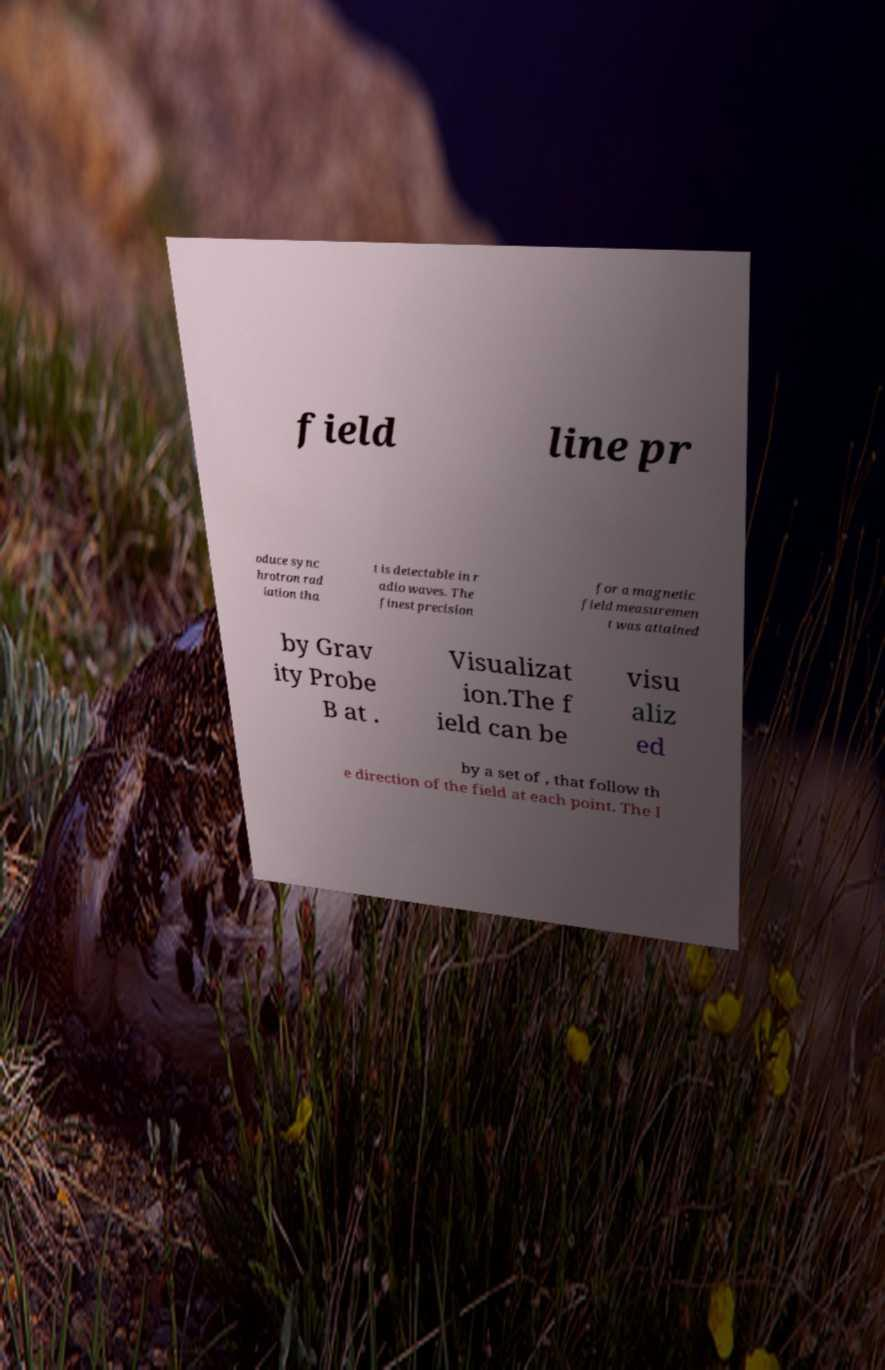What messages or text are displayed in this image? I need them in a readable, typed format. field line pr oduce sync hrotron rad iation tha t is detectable in r adio waves. The finest precision for a magnetic field measuremen t was attained by Grav ity Probe B at . Visualizat ion.The f ield can be visu aliz ed by a set of , that follow th e direction of the field at each point. The l 